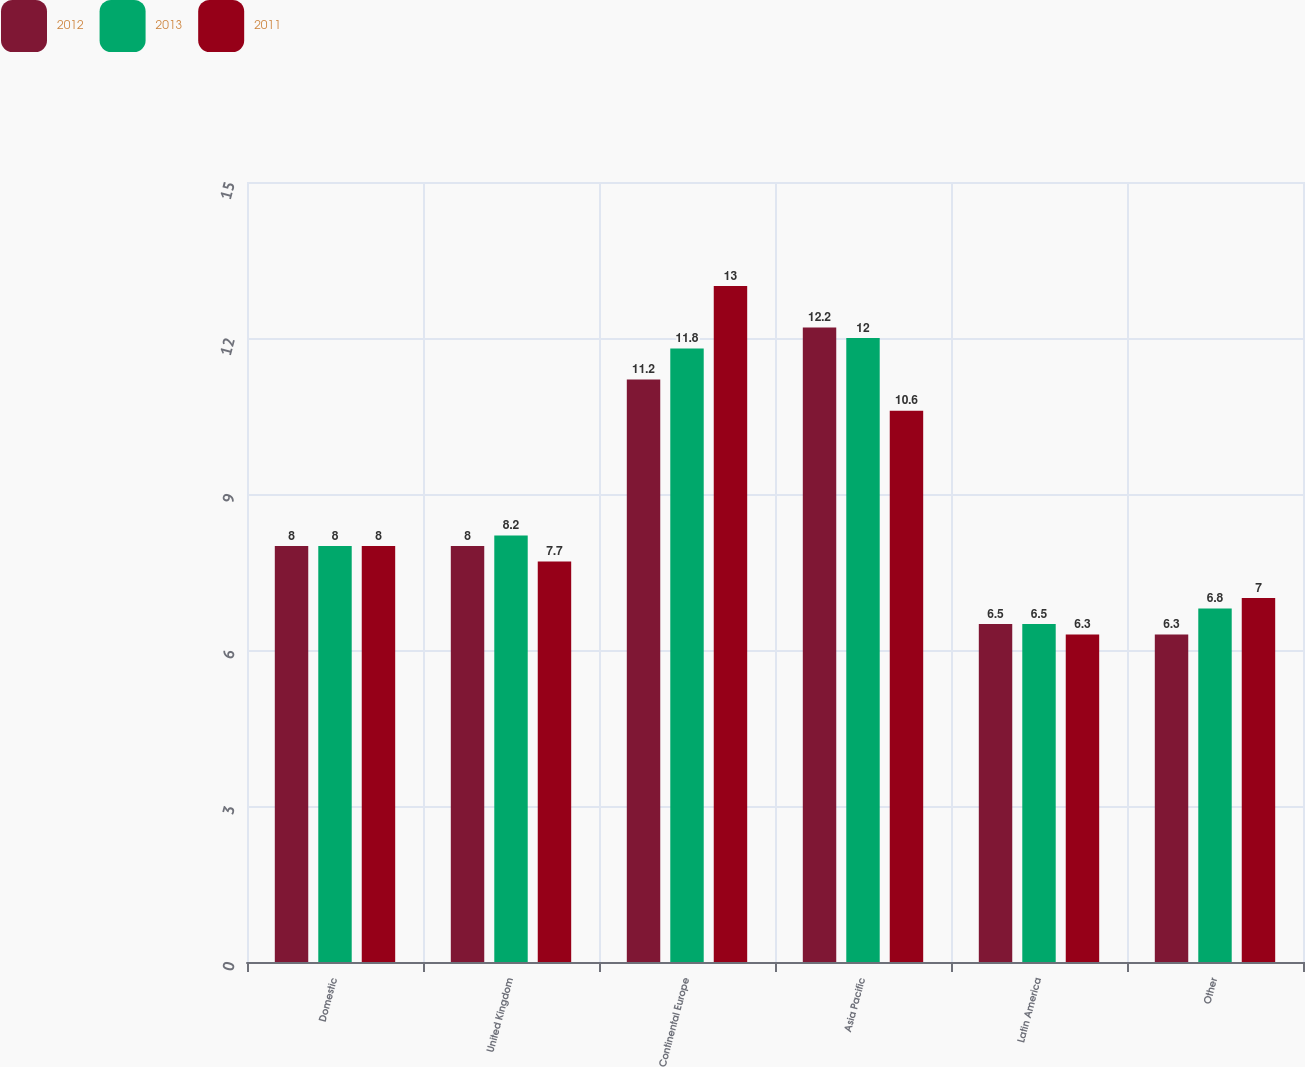Convert chart. <chart><loc_0><loc_0><loc_500><loc_500><stacked_bar_chart><ecel><fcel>Domestic<fcel>United Kingdom<fcel>Continental Europe<fcel>Asia Pacific<fcel>Latin America<fcel>Other<nl><fcel>2012<fcel>8<fcel>8<fcel>11.2<fcel>12.2<fcel>6.5<fcel>6.3<nl><fcel>2013<fcel>8<fcel>8.2<fcel>11.8<fcel>12<fcel>6.5<fcel>6.8<nl><fcel>2011<fcel>8<fcel>7.7<fcel>13<fcel>10.6<fcel>6.3<fcel>7<nl></chart> 